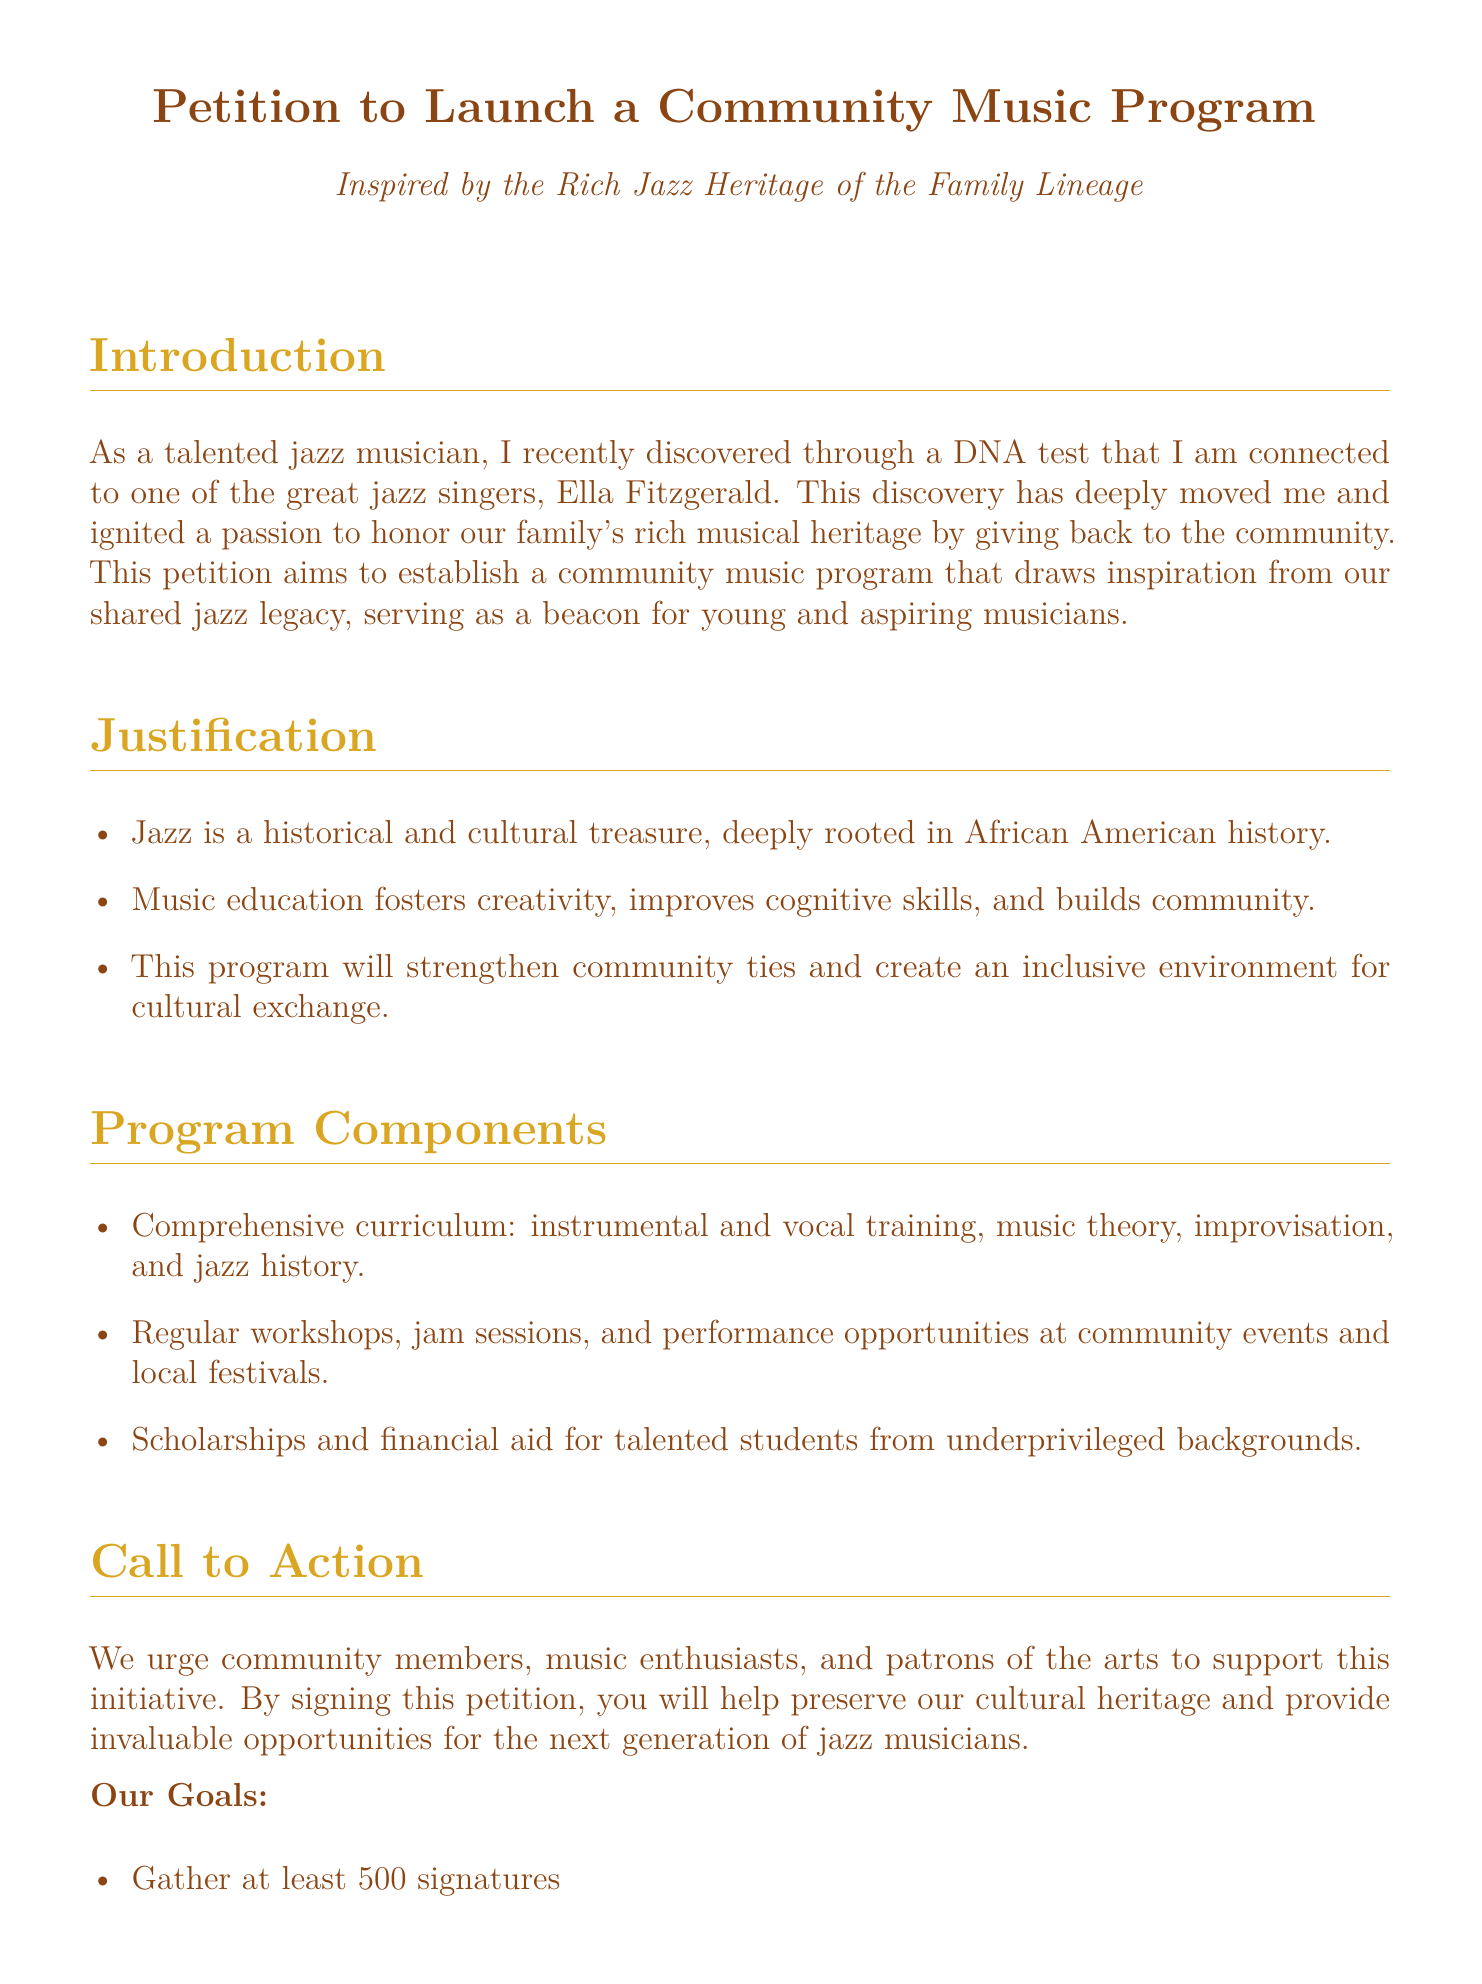What is the petition about? The petition aims to establish a community music program inspired by the rich jazz heritage of the family lineage.
Answer: Community music program Who is the famous jazz singer mentioned in the document? The document mentions that the musician is connected to one of the great jazz singers, Ella Fitzgerald.
Answer: Ella Fitzgerald How many signatures are needed for the petition? The goal is to gather at least 500 signatures as stated in the document.
Answer: 500 What is the initial funding amount required for the pilot phase? The document specifies that the initial funding needed is $50,000.
Answer: $50,000 When is the program scheduled to be inaugurated? The program is planned to be inaugurated during Jazz Appreciation Month in April.
Answer: April What type of training will the comprehensive curriculum include? The curriculum will include instrumental and vocal training, music theory, improvisation, and jazz history.
Answer: Instrumental and vocal training What is one of the program's goals related to funding? One of the goals stated is to secure initial funding for the pilot phase.
Answer: Secure initial funding What activity is included for community engagement? The program will host regular workshops, jam sessions, and performance opportunities at community events.
Answer: Workshops and jam sessions What is emphasized in the "Justification" section? The Justification section emphasizes that music education fosters creativity, improves cognitive skills, and builds community.
Answer: Music education fosters creativity 